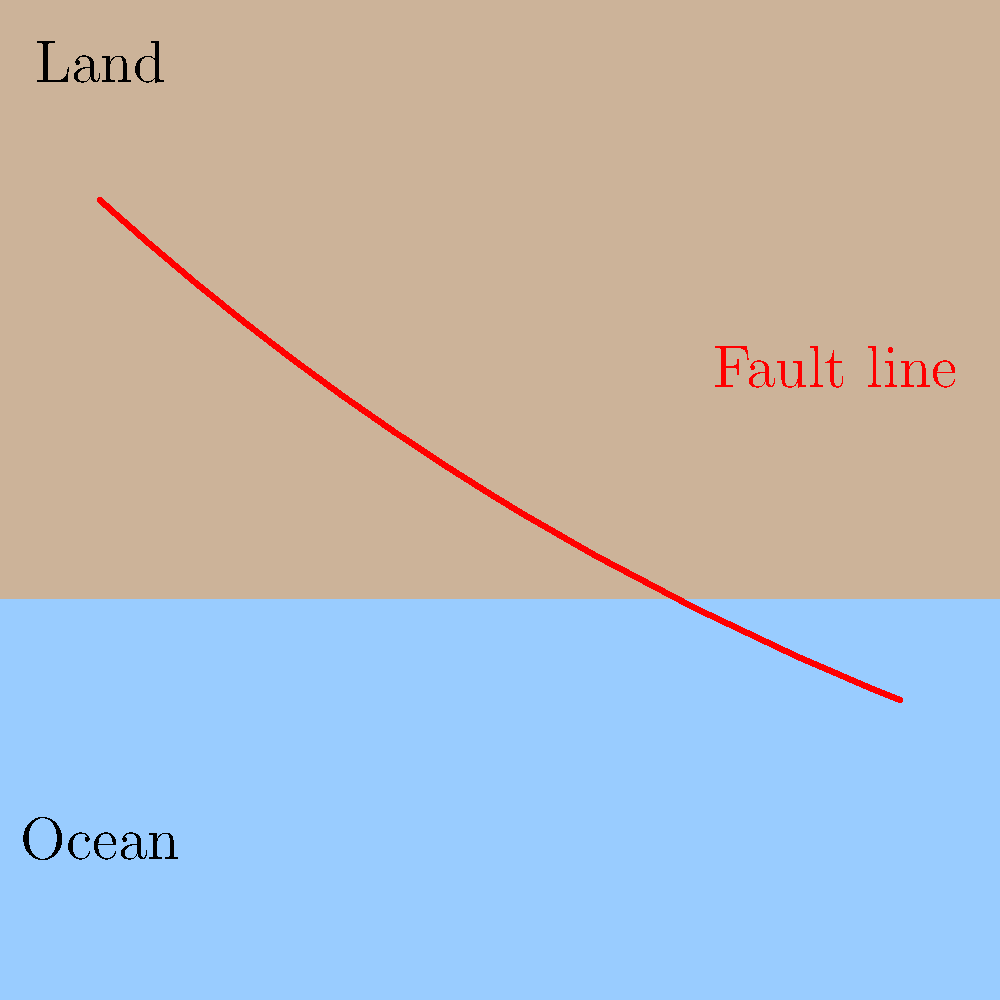Based on the satellite imagery provided, which geological feature is prominently displayed in red, and what implications does it have for seismic activity in the region? To identify the geological feature and its implications, let's analyze the image step-by-step:

1. The image shows a simplified representation of a landscape with land (beige) and water (blue) areas.

2. A prominent red line cuts across the image diagonally from the upper left to the lower right.

3. This red line is labeled as a "Fault line" in the image.

4. Fault lines are fractures in the Earth's crust where blocks of rock on either side have moved relative to one another.

5. The presence of a fault line has significant implications for seismic activity:
   a) Fault lines are the primary locations where earthquakes occur.
   b) As tectonic plates move and create stress along the fault, energy builds up.
   c) When this energy is released suddenly, it results in an earthquake.

6. The location of the fault line crossing from land to sea suggests:
   a) Potential for both onshore and offshore earthquakes.
   b) Risk of tsunamis if significant movement occurs along the offshore portion of the fault.

7. For a geologist studying seismic activities, this fault line would be a key area of focus for:
   a) Monitoring seismic activity
   b) Assessing earthquake risk for nearby populations
   c) Studying the geological history and future movement of the region

Therefore, the prominent red feature is a fault line, which implies that this region is prone to seismic activity and requires careful monitoring and study for earthquake risk assessment and management.
Answer: Fault line; indicates high potential for seismic activity (earthquakes) in the region. 